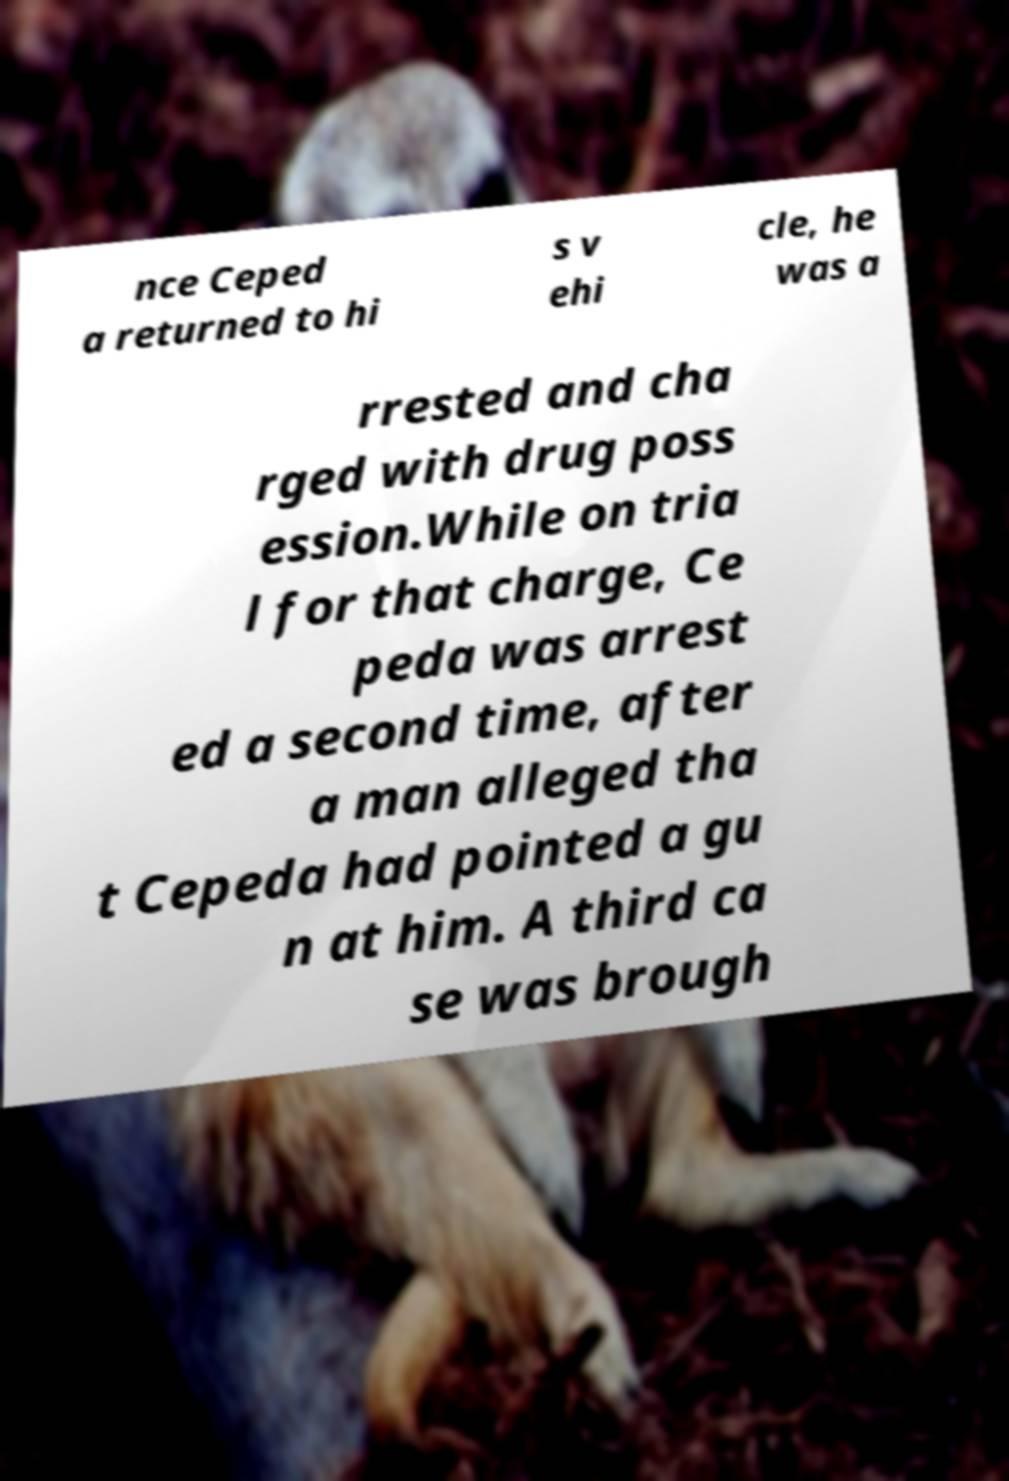There's text embedded in this image that I need extracted. Can you transcribe it verbatim? nce Ceped a returned to hi s v ehi cle, he was a rrested and cha rged with drug poss ession.While on tria l for that charge, Ce peda was arrest ed a second time, after a man alleged tha t Cepeda had pointed a gu n at him. A third ca se was brough 